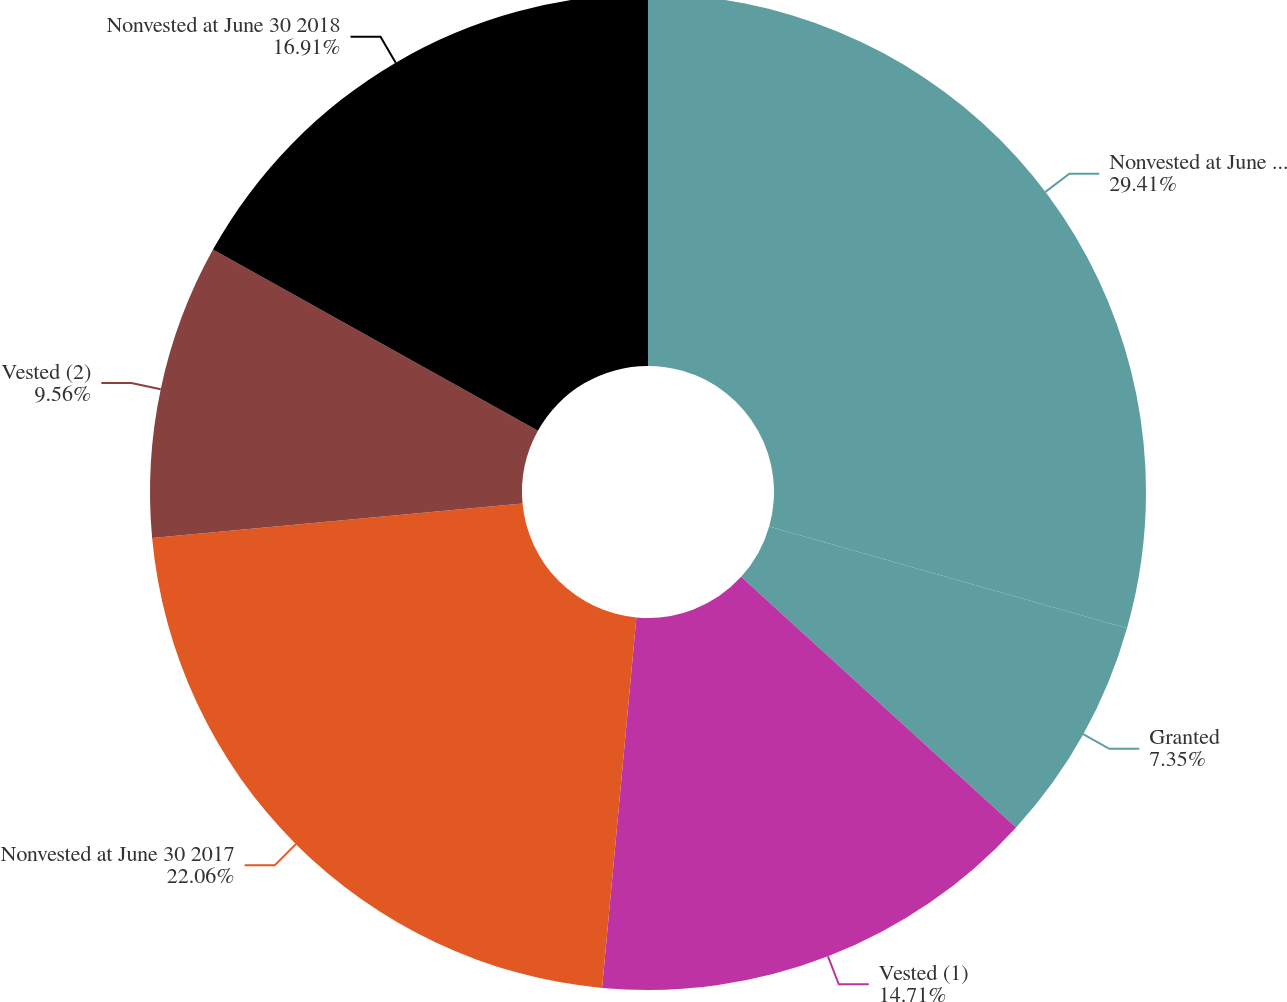Convert chart. <chart><loc_0><loc_0><loc_500><loc_500><pie_chart><fcel>Nonvested at June 30 2016<fcel>Granted<fcel>Vested (1)<fcel>Nonvested at June 30 2017<fcel>Vested (2)<fcel>Nonvested at June 30 2018<nl><fcel>29.41%<fcel>7.35%<fcel>14.71%<fcel>22.06%<fcel>9.56%<fcel>16.91%<nl></chart> 